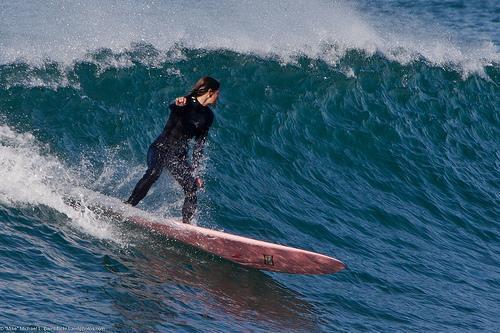How many people in the water?
Give a very brief answer. 1. 